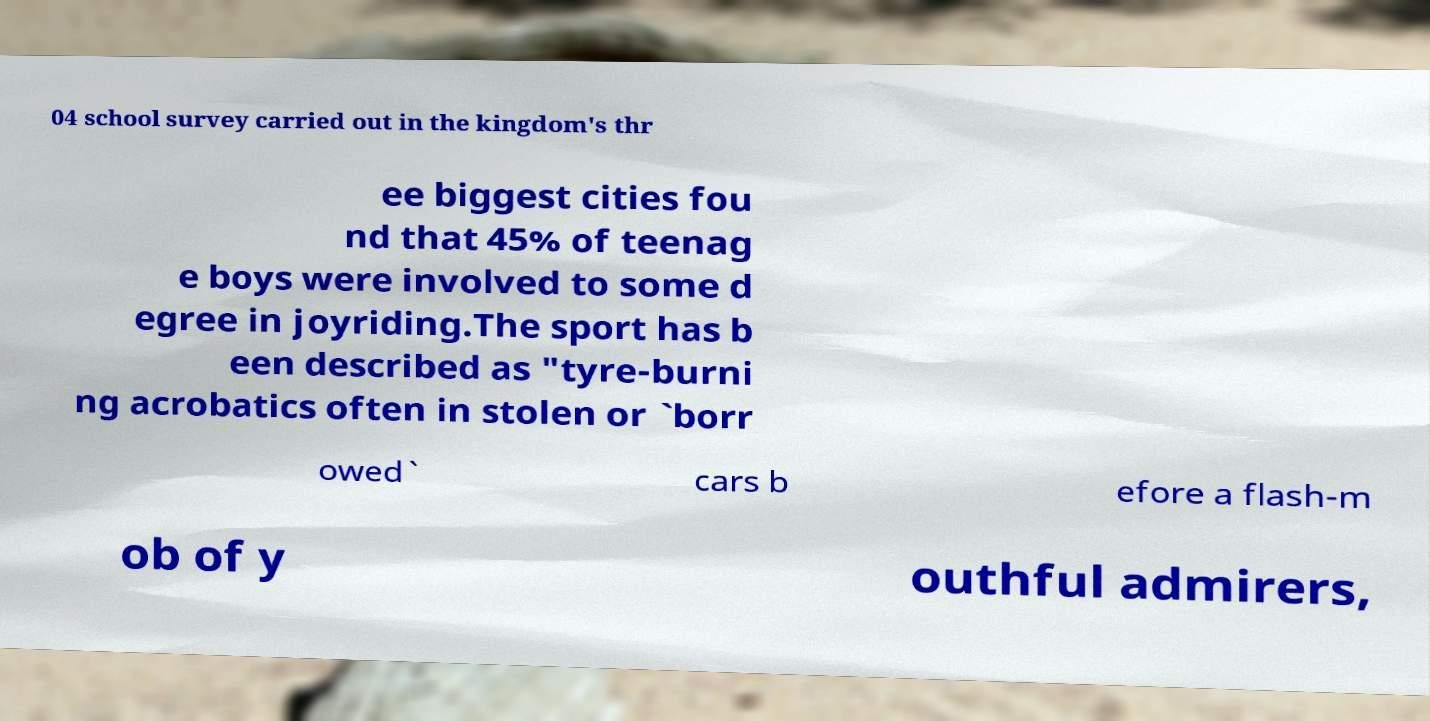For documentation purposes, I need the text within this image transcribed. Could you provide that? 04 school survey carried out in the kingdom's thr ee biggest cities fou nd that 45% of teenag e boys were involved to some d egree in joyriding.The sport has b een described as "tyre-burni ng acrobatics often in stolen or `borr owed` cars b efore a flash-m ob of y outhful admirers, 